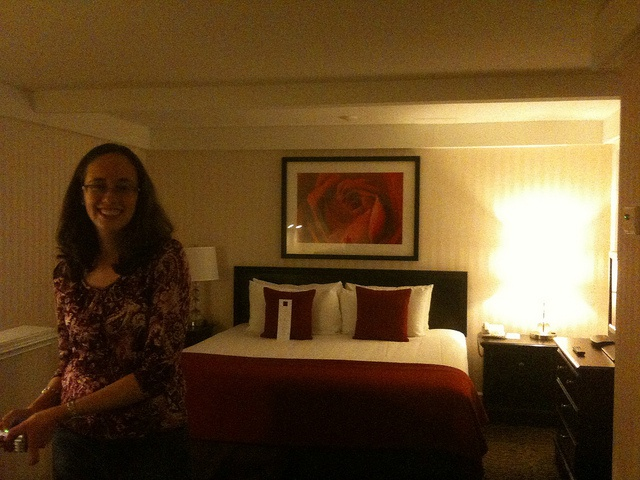Describe the objects in this image and their specific colors. I can see people in olive, black, maroon, and brown tones, bed in olive, black, and maroon tones, tv in olive, ivory, khaki, and maroon tones, and remote in olive, tan, and maroon tones in this image. 